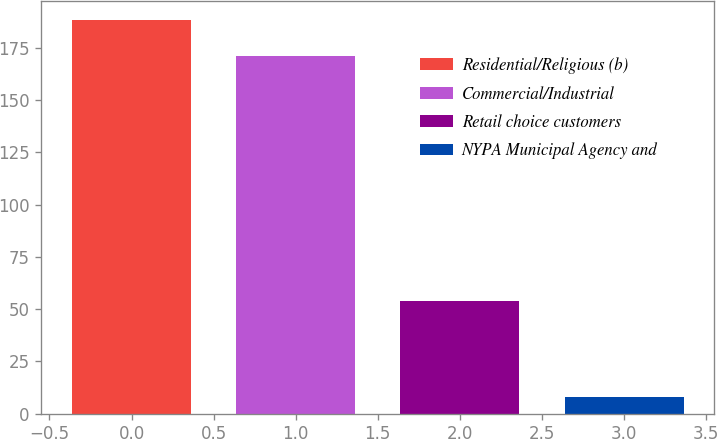Convert chart to OTSL. <chart><loc_0><loc_0><loc_500><loc_500><bar_chart><fcel>Residential/Religious (b)<fcel>Commercial/Industrial<fcel>Retail choice customers<fcel>NYPA Municipal Agency and<nl><fcel>188.2<fcel>171<fcel>54<fcel>8<nl></chart> 